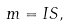<formula> <loc_0><loc_0><loc_500><loc_500>m = I S ,</formula> 